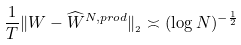<formula> <loc_0><loc_0><loc_500><loc_500>\frac { 1 } { T } \| W - \widehat { W } ^ { N , p r o d } \| _ { _ { 2 } } \asymp ( \log N ) ^ { - \frac { 1 } { 2 } }</formula> 